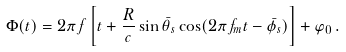<formula> <loc_0><loc_0><loc_500><loc_500>\Phi ( t ) = 2 \pi f \left [ t + \frac { R } { c } \sin \bar { \theta } _ { s } \cos ( 2 \pi f _ { m } t - \bar { \phi } _ { s } ) \right ] + \varphi _ { 0 } \, .</formula> 